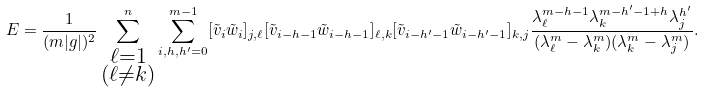Convert formula to latex. <formula><loc_0><loc_0><loc_500><loc_500>E = \frac { 1 } { ( m | g | ) ^ { 2 } } \sum _ { \substack { \ell = 1 \\ ( \ell \neq k ) } } ^ { n } \sum _ { i , h , h ^ { \prime } = 0 } ^ { m - 1 } [ \tilde { v } _ { i } \tilde { w } _ { i } ] _ { j , \ell } [ \tilde { v } _ { i - h - 1 } \tilde { w } _ { i - h - 1 } ] _ { \ell , k } [ \tilde { v } _ { i - h ^ { \prime } - 1 } \tilde { w } _ { i - h ^ { \prime } - 1 } ] _ { k , j } \frac { \lambda _ { \ell } ^ { m - h - 1 } \lambda _ { k } ^ { m - h ^ { \prime } - 1 + h } \lambda _ { j } ^ { h ^ { \prime } } } { ( \lambda _ { \ell } ^ { m } - \lambda _ { k } ^ { m } ) ( \lambda _ { k } ^ { m } - \lambda _ { j } ^ { m } ) } .</formula> 